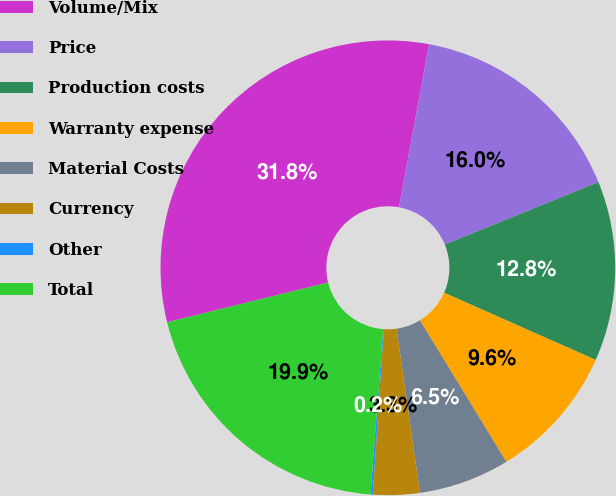Convert chart. <chart><loc_0><loc_0><loc_500><loc_500><pie_chart><fcel>Volume/Mix<fcel>Price<fcel>Production costs<fcel>Warranty expense<fcel>Material Costs<fcel>Currency<fcel>Other<fcel>Total<nl><fcel>31.75%<fcel>15.95%<fcel>12.79%<fcel>9.63%<fcel>6.47%<fcel>3.31%<fcel>0.16%<fcel>19.93%<nl></chart> 